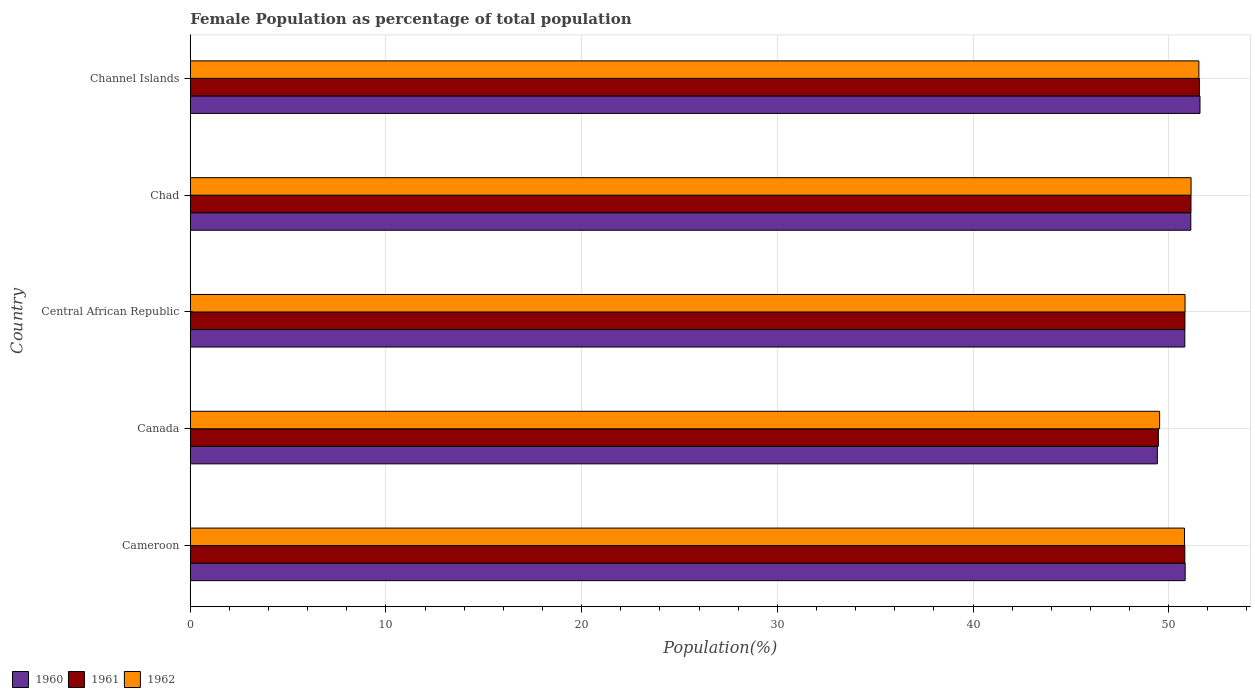How many different coloured bars are there?
Keep it short and to the point. 3. How many groups of bars are there?
Ensure brevity in your answer.  5. Are the number of bars per tick equal to the number of legend labels?
Offer a terse response. Yes. How many bars are there on the 2nd tick from the top?
Make the answer very short. 3. What is the label of the 3rd group of bars from the top?
Your response must be concise. Central African Republic. What is the female population in in 1961 in Canada?
Keep it short and to the point. 49.47. Across all countries, what is the maximum female population in in 1961?
Provide a succinct answer. 51.57. Across all countries, what is the minimum female population in in 1961?
Keep it short and to the point. 49.47. In which country was the female population in in 1960 maximum?
Your answer should be compact. Channel Islands. In which country was the female population in in 1962 minimum?
Give a very brief answer. Canada. What is the total female population in in 1961 in the graph?
Your answer should be compact. 253.84. What is the difference between the female population in in 1962 in Central African Republic and that in Chad?
Keep it short and to the point. -0.31. What is the difference between the female population in in 1961 in Canada and the female population in in 1960 in Channel Islands?
Provide a short and direct response. -2.13. What is the average female population in in 1960 per country?
Offer a terse response. 50.76. What is the difference between the female population in in 1962 and female population in in 1960 in Cameroon?
Keep it short and to the point. -0.04. In how many countries, is the female population in in 1961 greater than 50 %?
Provide a succinct answer. 4. What is the ratio of the female population in in 1962 in Central African Republic to that in Channel Islands?
Your answer should be compact. 0.99. Is the female population in in 1961 in Cameroon less than that in Chad?
Offer a terse response. Yes. Is the difference between the female population in in 1962 in Canada and Central African Republic greater than the difference between the female population in in 1960 in Canada and Central African Republic?
Offer a very short reply. Yes. What is the difference between the highest and the second highest female population in in 1962?
Your answer should be very brief. 0.4. What is the difference between the highest and the lowest female population in in 1961?
Offer a terse response. 2.1. In how many countries, is the female population in in 1962 greater than the average female population in in 1962 taken over all countries?
Your response must be concise. 4. Is the sum of the female population in in 1962 in Central African Republic and Chad greater than the maximum female population in in 1960 across all countries?
Make the answer very short. Yes. What does the 3rd bar from the top in Canada represents?
Ensure brevity in your answer.  1960. Is it the case that in every country, the sum of the female population in in 1961 and female population in in 1962 is greater than the female population in in 1960?
Ensure brevity in your answer.  Yes. How many bars are there?
Provide a short and direct response. 15. What is the difference between two consecutive major ticks on the X-axis?
Your response must be concise. 10. Are the values on the major ticks of X-axis written in scientific E-notation?
Ensure brevity in your answer.  No. Does the graph contain any zero values?
Ensure brevity in your answer.  No. Where does the legend appear in the graph?
Make the answer very short. Bottom left. How many legend labels are there?
Give a very brief answer. 3. What is the title of the graph?
Provide a short and direct response. Female Population as percentage of total population. Does "1998" appear as one of the legend labels in the graph?
Your response must be concise. No. What is the label or title of the X-axis?
Your answer should be very brief. Population(%). What is the Population(%) of 1960 in Cameroon?
Provide a short and direct response. 50.84. What is the Population(%) in 1961 in Cameroon?
Make the answer very short. 50.83. What is the Population(%) of 1962 in Cameroon?
Your answer should be compact. 50.81. What is the Population(%) of 1960 in Canada?
Ensure brevity in your answer.  49.42. What is the Population(%) in 1961 in Canada?
Ensure brevity in your answer.  49.47. What is the Population(%) in 1962 in Canada?
Your answer should be very brief. 49.54. What is the Population(%) of 1960 in Central African Republic?
Make the answer very short. 50.82. What is the Population(%) of 1961 in Central African Republic?
Your answer should be compact. 50.83. What is the Population(%) of 1962 in Central African Republic?
Provide a succinct answer. 50.84. What is the Population(%) of 1960 in Chad?
Your answer should be very brief. 51.13. What is the Population(%) of 1961 in Chad?
Provide a succinct answer. 51.14. What is the Population(%) of 1962 in Chad?
Your answer should be very brief. 51.14. What is the Population(%) in 1960 in Channel Islands?
Your answer should be very brief. 51.6. What is the Population(%) of 1961 in Channel Islands?
Keep it short and to the point. 51.57. What is the Population(%) in 1962 in Channel Islands?
Ensure brevity in your answer.  51.54. Across all countries, what is the maximum Population(%) in 1960?
Keep it short and to the point. 51.6. Across all countries, what is the maximum Population(%) in 1961?
Offer a very short reply. 51.57. Across all countries, what is the maximum Population(%) of 1962?
Provide a succinct answer. 51.54. Across all countries, what is the minimum Population(%) of 1960?
Your response must be concise. 49.42. Across all countries, what is the minimum Population(%) of 1961?
Give a very brief answer. 49.47. Across all countries, what is the minimum Population(%) in 1962?
Provide a succinct answer. 49.54. What is the total Population(%) in 1960 in the graph?
Offer a terse response. 253.82. What is the total Population(%) in 1961 in the graph?
Keep it short and to the point. 253.84. What is the total Population(%) in 1962 in the graph?
Provide a succinct answer. 253.87. What is the difference between the Population(%) in 1960 in Cameroon and that in Canada?
Your response must be concise. 1.42. What is the difference between the Population(%) in 1961 in Cameroon and that in Canada?
Your answer should be compact. 1.35. What is the difference between the Population(%) in 1962 in Cameroon and that in Canada?
Keep it short and to the point. 1.27. What is the difference between the Population(%) of 1960 in Cameroon and that in Central African Republic?
Your answer should be very brief. 0.02. What is the difference between the Population(%) of 1961 in Cameroon and that in Central African Republic?
Ensure brevity in your answer.  -0. What is the difference between the Population(%) in 1962 in Cameroon and that in Central African Republic?
Your answer should be compact. -0.03. What is the difference between the Population(%) in 1960 in Cameroon and that in Chad?
Offer a very short reply. -0.29. What is the difference between the Population(%) of 1961 in Cameroon and that in Chad?
Ensure brevity in your answer.  -0.31. What is the difference between the Population(%) in 1962 in Cameroon and that in Chad?
Make the answer very short. -0.34. What is the difference between the Population(%) of 1960 in Cameroon and that in Channel Islands?
Your answer should be compact. -0.76. What is the difference between the Population(%) in 1961 in Cameroon and that in Channel Islands?
Offer a very short reply. -0.75. What is the difference between the Population(%) of 1962 in Cameroon and that in Channel Islands?
Give a very brief answer. -0.74. What is the difference between the Population(%) in 1960 in Canada and that in Central African Republic?
Provide a succinct answer. -1.4. What is the difference between the Population(%) of 1961 in Canada and that in Central African Republic?
Provide a short and direct response. -1.36. What is the difference between the Population(%) in 1962 in Canada and that in Central African Republic?
Offer a terse response. -1.3. What is the difference between the Population(%) of 1960 in Canada and that in Chad?
Give a very brief answer. -1.71. What is the difference between the Population(%) of 1961 in Canada and that in Chad?
Your response must be concise. -1.67. What is the difference between the Population(%) in 1962 in Canada and that in Chad?
Ensure brevity in your answer.  -1.61. What is the difference between the Population(%) of 1960 in Canada and that in Channel Islands?
Offer a terse response. -2.18. What is the difference between the Population(%) of 1961 in Canada and that in Channel Islands?
Give a very brief answer. -2.1. What is the difference between the Population(%) of 1962 in Canada and that in Channel Islands?
Make the answer very short. -2.01. What is the difference between the Population(%) of 1960 in Central African Republic and that in Chad?
Your response must be concise. -0.31. What is the difference between the Population(%) of 1961 in Central African Republic and that in Chad?
Your answer should be compact. -0.31. What is the difference between the Population(%) in 1962 in Central African Republic and that in Chad?
Ensure brevity in your answer.  -0.31. What is the difference between the Population(%) of 1960 in Central African Republic and that in Channel Islands?
Provide a short and direct response. -0.78. What is the difference between the Population(%) in 1961 in Central African Republic and that in Channel Islands?
Keep it short and to the point. -0.74. What is the difference between the Population(%) of 1962 in Central African Republic and that in Channel Islands?
Offer a very short reply. -0.71. What is the difference between the Population(%) in 1960 in Chad and that in Channel Islands?
Offer a terse response. -0.47. What is the difference between the Population(%) of 1961 in Chad and that in Channel Islands?
Ensure brevity in your answer.  -0.43. What is the difference between the Population(%) of 1962 in Chad and that in Channel Islands?
Your response must be concise. -0.4. What is the difference between the Population(%) in 1960 in Cameroon and the Population(%) in 1961 in Canada?
Ensure brevity in your answer.  1.37. What is the difference between the Population(%) in 1960 in Cameroon and the Population(%) in 1962 in Canada?
Your answer should be compact. 1.31. What is the difference between the Population(%) of 1961 in Cameroon and the Population(%) of 1962 in Canada?
Provide a succinct answer. 1.29. What is the difference between the Population(%) in 1960 in Cameroon and the Population(%) in 1961 in Central African Republic?
Your answer should be compact. 0.01. What is the difference between the Population(%) in 1960 in Cameroon and the Population(%) in 1962 in Central African Republic?
Keep it short and to the point. 0.01. What is the difference between the Population(%) in 1961 in Cameroon and the Population(%) in 1962 in Central African Republic?
Offer a very short reply. -0.01. What is the difference between the Population(%) in 1960 in Cameroon and the Population(%) in 1961 in Chad?
Your response must be concise. -0.3. What is the difference between the Population(%) of 1960 in Cameroon and the Population(%) of 1962 in Chad?
Your response must be concise. -0.3. What is the difference between the Population(%) in 1961 in Cameroon and the Population(%) in 1962 in Chad?
Your answer should be very brief. -0.32. What is the difference between the Population(%) in 1960 in Cameroon and the Population(%) in 1961 in Channel Islands?
Offer a very short reply. -0.73. What is the difference between the Population(%) in 1960 in Cameroon and the Population(%) in 1962 in Channel Islands?
Your answer should be compact. -0.7. What is the difference between the Population(%) of 1961 in Cameroon and the Population(%) of 1962 in Channel Islands?
Make the answer very short. -0.72. What is the difference between the Population(%) of 1960 in Canada and the Population(%) of 1961 in Central African Republic?
Give a very brief answer. -1.41. What is the difference between the Population(%) of 1960 in Canada and the Population(%) of 1962 in Central African Republic?
Your answer should be very brief. -1.42. What is the difference between the Population(%) of 1961 in Canada and the Population(%) of 1962 in Central African Republic?
Ensure brevity in your answer.  -1.36. What is the difference between the Population(%) in 1960 in Canada and the Population(%) in 1961 in Chad?
Your response must be concise. -1.72. What is the difference between the Population(%) of 1960 in Canada and the Population(%) of 1962 in Chad?
Keep it short and to the point. -1.72. What is the difference between the Population(%) in 1961 in Canada and the Population(%) in 1962 in Chad?
Ensure brevity in your answer.  -1.67. What is the difference between the Population(%) in 1960 in Canada and the Population(%) in 1961 in Channel Islands?
Offer a terse response. -2.15. What is the difference between the Population(%) in 1960 in Canada and the Population(%) in 1962 in Channel Islands?
Keep it short and to the point. -2.12. What is the difference between the Population(%) of 1961 in Canada and the Population(%) of 1962 in Channel Islands?
Offer a very short reply. -2.07. What is the difference between the Population(%) of 1960 in Central African Republic and the Population(%) of 1961 in Chad?
Make the answer very short. -0.32. What is the difference between the Population(%) in 1960 in Central African Republic and the Population(%) in 1962 in Chad?
Your response must be concise. -0.32. What is the difference between the Population(%) of 1961 in Central African Republic and the Population(%) of 1962 in Chad?
Ensure brevity in your answer.  -0.31. What is the difference between the Population(%) in 1960 in Central African Republic and the Population(%) in 1961 in Channel Islands?
Your answer should be compact. -0.75. What is the difference between the Population(%) of 1960 in Central African Republic and the Population(%) of 1962 in Channel Islands?
Make the answer very short. -0.72. What is the difference between the Population(%) in 1961 in Central African Republic and the Population(%) in 1962 in Channel Islands?
Your response must be concise. -0.71. What is the difference between the Population(%) in 1960 in Chad and the Population(%) in 1961 in Channel Islands?
Ensure brevity in your answer.  -0.44. What is the difference between the Population(%) in 1960 in Chad and the Population(%) in 1962 in Channel Islands?
Ensure brevity in your answer.  -0.41. What is the difference between the Population(%) in 1961 in Chad and the Population(%) in 1962 in Channel Islands?
Give a very brief answer. -0.4. What is the average Population(%) in 1960 per country?
Give a very brief answer. 50.76. What is the average Population(%) in 1961 per country?
Make the answer very short. 50.77. What is the average Population(%) in 1962 per country?
Keep it short and to the point. 50.77. What is the difference between the Population(%) of 1960 and Population(%) of 1961 in Cameroon?
Your response must be concise. 0.02. What is the difference between the Population(%) in 1960 and Population(%) in 1962 in Cameroon?
Offer a terse response. 0.04. What is the difference between the Population(%) in 1961 and Population(%) in 1962 in Cameroon?
Give a very brief answer. 0.02. What is the difference between the Population(%) of 1960 and Population(%) of 1961 in Canada?
Make the answer very short. -0.05. What is the difference between the Population(%) of 1960 and Population(%) of 1962 in Canada?
Offer a terse response. -0.12. What is the difference between the Population(%) in 1961 and Population(%) in 1962 in Canada?
Keep it short and to the point. -0.06. What is the difference between the Population(%) in 1960 and Population(%) in 1961 in Central African Republic?
Give a very brief answer. -0.01. What is the difference between the Population(%) in 1960 and Population(%) in 1962 in Central African Republic?
Your answer should be very brief. -0.01. What is the difference between the Population(%) in 1961 and Population(%) in 1962 in Central African Republic?
Keep it short and to the point. -0.01. What is the difference between the Population(%) of 1960 and Population(%) of 1961 in Chad?
Your response must be concise. -0.01. What is the difference between the Population(%) in 1960 and Population(%) in 1962 in Chad?
Make the answer very short. -0.01. What is the difference between the Population(%) of 1961 and Population(%) of 1962 in Chad?
Offer a very short reply. -0. What is the difference between the Population(%) in 1960 and Population(%) in 1961 in Channel Islands?
Offer a very short reply. 0.03. What is the difference between the Population(%) in 1960 and Population(%) in 1962 in Channel Islands?
Give a very brief answer. 0.06. What is the difference between the Population(%) in 1961 and Population(%) in 1962 in Channel Islands?
Make the answer very short. 0.03. What is the ratio of the Population(%) in 1960 in Cameroon to that in Canada?
Your answer should be very brief. 1.03. What is the ratio of the Population(%) of 1961 in Cameroon to that in Canada?
Ensure brevity in your answer.  1.03. What is the ratio of the Population(%) in 1962 in Cameroon to that in Canada?
Make the answer very short. 1.03. What is the ratio of the Population(%) of 1960 in Cameroon to that in Central African Republic?
Ensure brevity in your answer.  1. What is the ratio of the Population(%) in 1960 in Cameroon to that in Chad?
Offer a terse response. 0.99. What is the ratio of the Population(%) of 1960 in Cameroon to that in Channel Islands?
Your answer should be compact. 0.99. What is the ratio of the Population(%) of 1961 in Cameroon to that in Channel Islands?
Provide a succinct answer. 0.99. What is the ratio of the Population(%) of 1962 in Cameroon to that in Channel Islands?
Offer a terse response. 0.99. What is the ratio of the Population(%) in 1960 in Canada to that in Central African Republic?
Your answer should be very brief. 0.97. What is the ratio of the Population(%) of 1961 in Canada to that in Central African Republic?
Make the answer very short. 0.97. What is the ratio of the Population(%) in 1962 in Canada to that in Central African Republic?
Make the answer very short. 0.97. What is the ratio of the Population(%) of 1960 in Canada to that in Chad?
Provide a short and direct response. 0.97. What is the ratio of the Population(%) of 1961 in Canada to that in Chad?
Your answer should be very brief. 0.97. What is the ratio of the Population(%) in 1962 in Canada to that in Chad?
Offer a terse response. 0.97. What is the ratio of the Population(%) in 1960 in Canada to that in Channel Islands?
Provide a succinct answer. 0.96. What is the ratio of the Population(%) in 1961 in Canada to that in Channel Islands?
Offer a terse response. 0.96. What is the ratio of the Population(%) of 1962 in Canada to that in Channel Islands?
Make the answer very short. 0.96. What is the ratio of the Population(%) in 1960 in Central African Republic to that in Chad?
Ensure brevity in your answer.  0.99. What is the ratio of the Population(%) in 1960 in Central African Republic to that in Channel Islands?
Make the answer very short. 0.98. What is the ratio of the Population(%) in 1961 in Central African Republic to that in Channel Islands?
Offer a very short reply. 0.99. What is the ratio of the Population(%) in 1962 in Central African Republic to that in Channel Islands?
Your answer should be compact. 0.99. What is the ratio of the Population(%) of 1960 in Chad to that in Channel Islands?
Provide a short and direct response. 0.99. What is the ratio of the Population(%) of 1961 in Chad to that in Channel Islands?
Give a very brief answer. 0.99. What is the ratio of the Population(%) of 1962 in Chad to that in Channel Islands?
Your answer should be very brief. 0.99. What is the difference between the highest and the second highest Population(%) in 1960?
Make the answer very short. 0.47. What is the difference between the highest and the second highest Population(%) of 1961?
Keep it short and to the point. 0.43. What is the difference between the highest and the second highest Population(%) of 1962?
Provide a short and direct response. 0.4. What is the difference between the highest and the lowest Population(%) in 1960?
Provide a short and direct response. 2.18. What is the difference between the highest and the lowest Population(%) of 1961?
Provide a succinct answer. 2.1. What is the difference between the highest and the lowest Population(%) in 1962?
Your response must be concise. 2.01. 